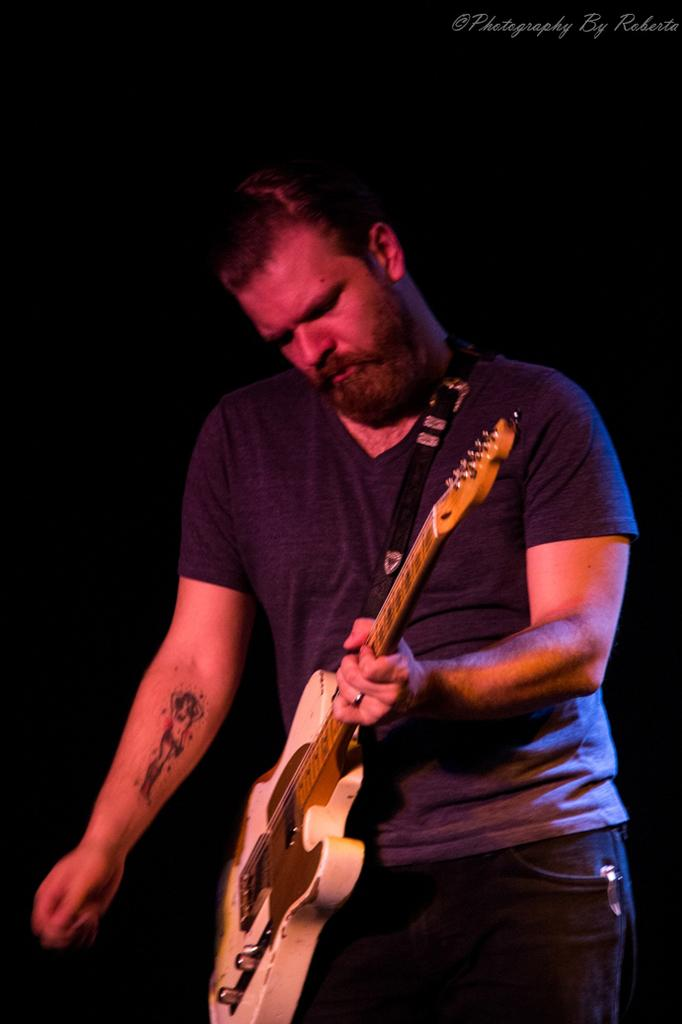What is the main subject of the image? The main subject of the image is a musician. What is the musician doing in the image? The musician is standing in the image. What is the musician holding in his hand? The musician is holding a musical instrument in his hand. What type of cloud can be seen in the image? There is no cloud present in the image; it features a musician standing and holding a musical instrument. What liquid is being poured from the bucket in the image? There is no bucket or liquid present in the image. 